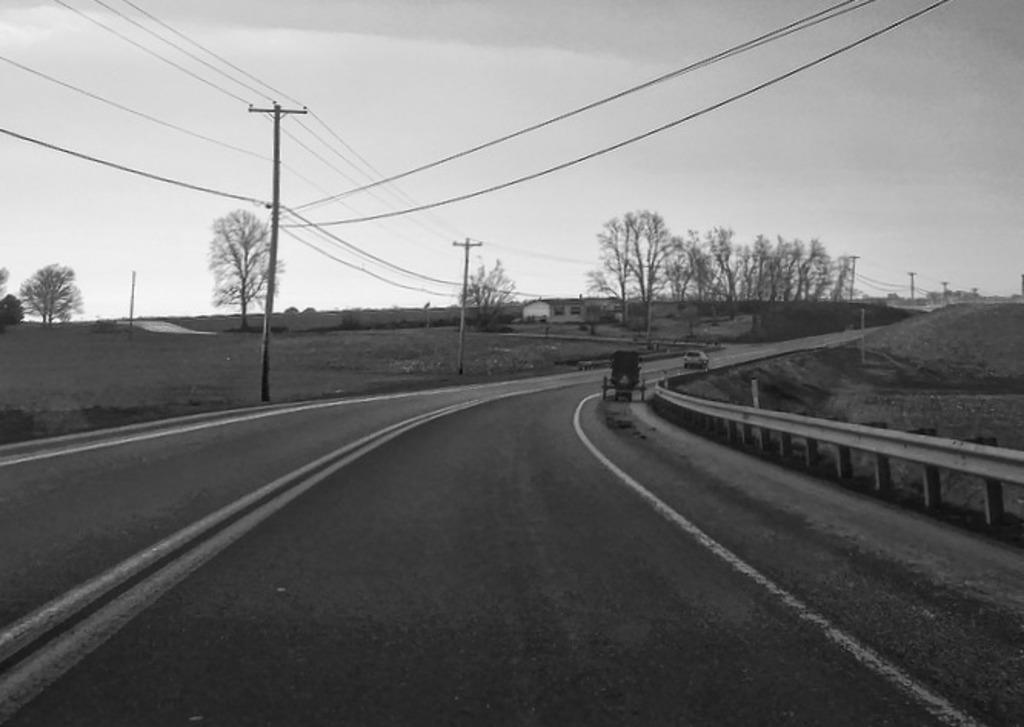What is the color scheme of the image? The image is black and white. What can be seen moving on the road in the image? There are two vehicles moving on the road in the image. What structures are present along the road in the image? There are utility poles in the image. What type of vegetation is visible in the image? There are trees in the image. What type of building is present in the image? There is a house in the image. What is visible at the top of the image? The sky is visible in the image. How many arms are visible on the trees in the image? There are no arms visible on the trees in the image, as trees do not have arms. Can you see any frogs hopping on the road in the image? There are no frogs present in the image; it features two vehicles moving on the road. 